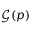Convert formula to latex. <formula><loc_0><loc_0><loc_500><loc_500>\mathcal { G } ( p )</formula> 